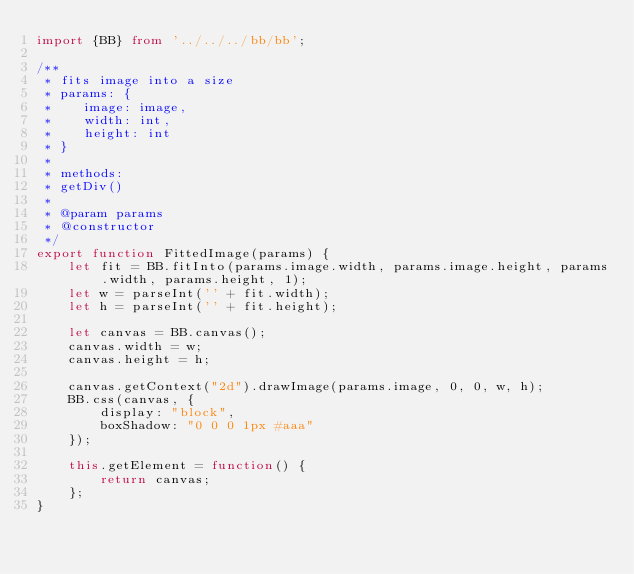<code> <loc_0><loc_0><loc_500><loc_500><_TypeScript_>import {BB} from '../../../bb/bb';

/**
 * fits image into a size
 * params: {
 *    image: image,
 *    width: int,
 *    height: int
 * }
 *
 * methods:
 * getDiv()
 *
 * @param params
 * @constructor
 */
export function FittedImage(params) {
    let fit = BB.fitInto(params.image.width, params.image.height, params.width, params.height, 1);
    let w = parseInt('' + fit.width);
    let h = parseInt('' + fit.height);

    let canvas = BB.canvas();
    canvas.width = w;
    canvas.height = h;

    canvas.getContext("2d").drawImage(params.image, 0, 0, w, h);
    BB.css(canvas, {
        display: "block",
        boxShadow: "0 0 0 1px #aaa"
    });

    this.getElement = function() {
        return canvas;
    };
}</code> 